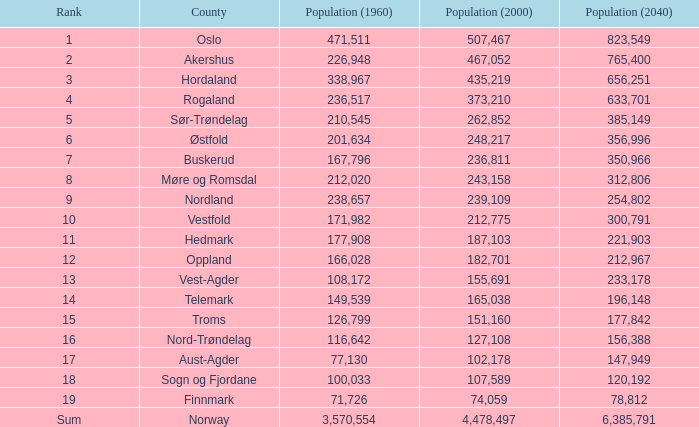What was the population size of a county in 1960 that had 467,052 people in 2000 and 78,812 in 2040? None. 